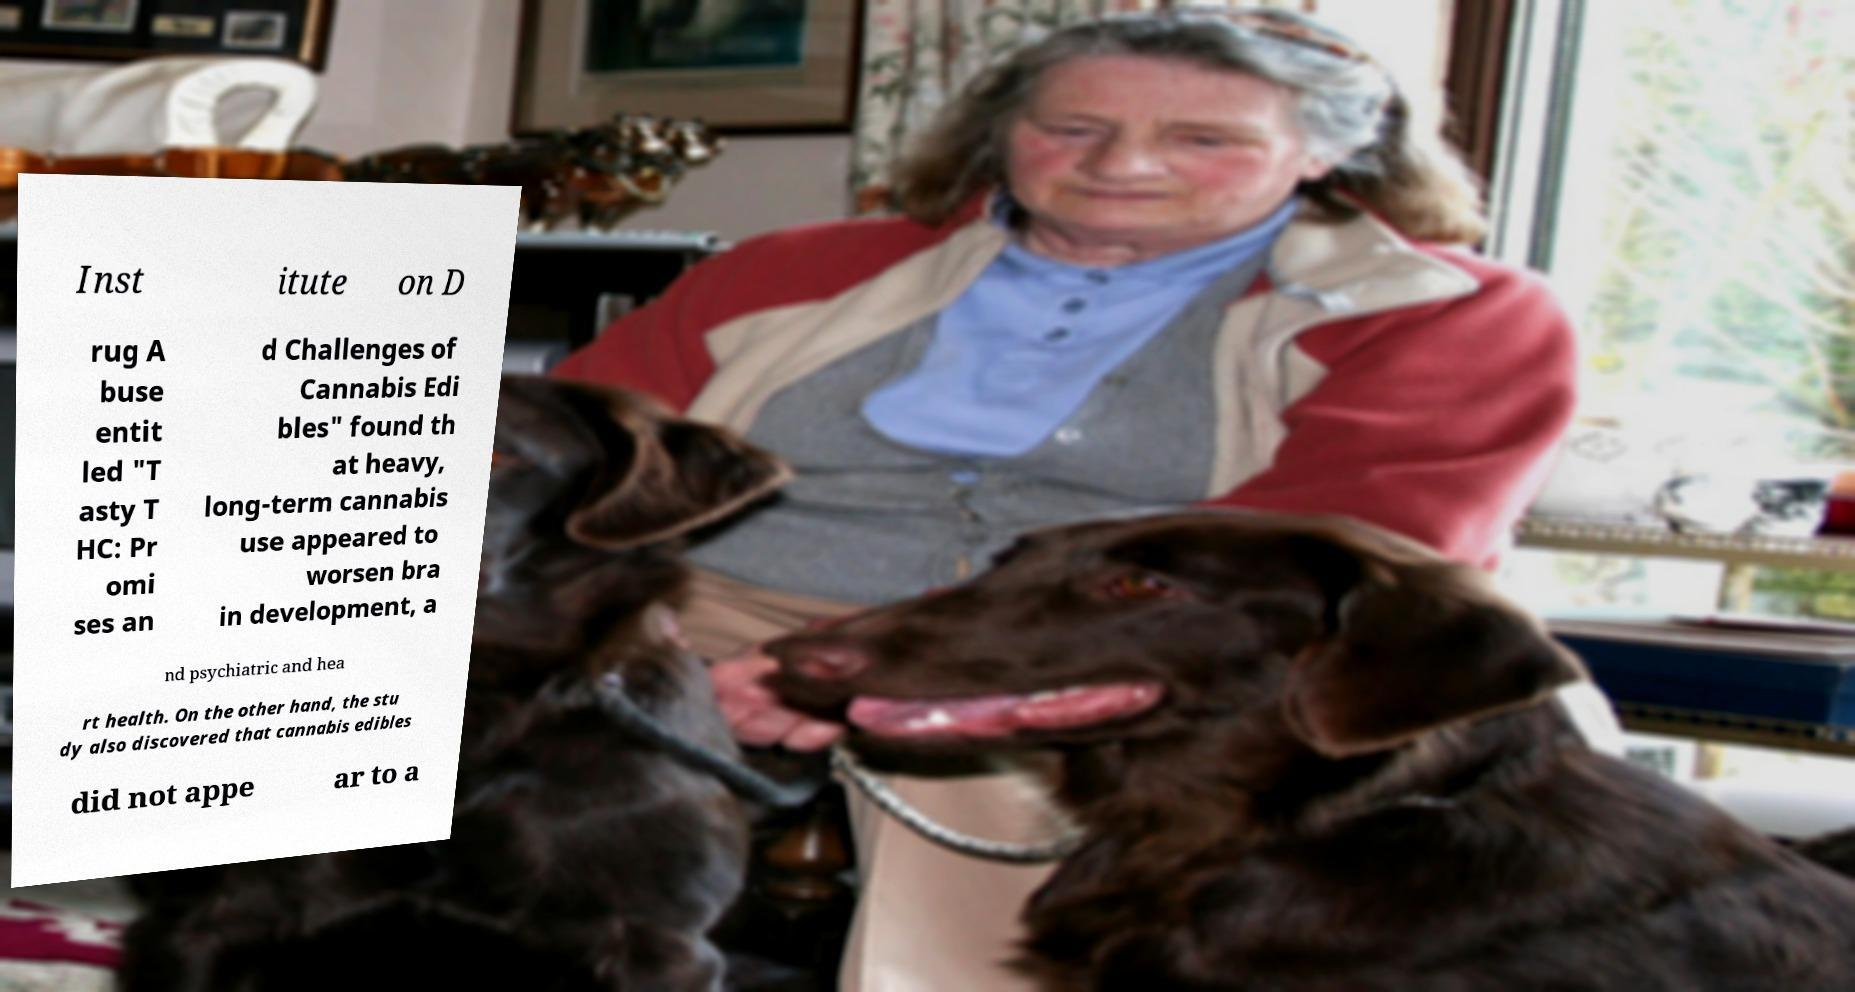For documentation purposes, I need the text within this image transcribed. Could you provide that? Inst itute on D rug A buse entit led "T asty T HC: Pr omi ses an d Challenges of Cannabis Edi bles" found th at heavy, long-term cannabis use appeared to worsen bra in development, a nd psychiatric and hea rt health. On the other hand, the stu dy also discovered that cannabis edibles did not appe ar to a 